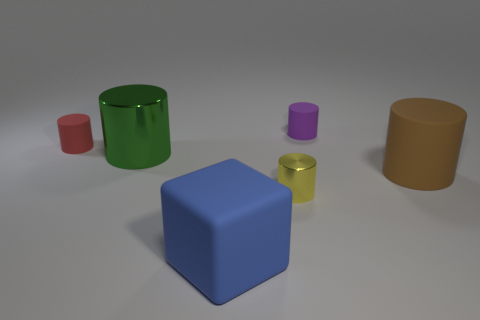Are there more big brown things that are left of the blue rubber thing than big metallic cylinders that are in front of the red rubber cylinder?
Make the answer very short. No. How many other things are there of the same size as the brown cylinder?
Offer a terse response. 2. Are the large cylinder to the right of the tiny purple matte cylinder and the green cylinder made of the same material?
Offer a very short reply. No. What number of other things are there of the same color as the big metal cylinder?
Provide a succinct answer. 0. How many other objects are there of the same shape as the blue object?
Provide a short and direct response. 0. Do the tiny thing behind the tiny red cylinder and the big thing behind the large brown thing have the same shape?
Provide a short and direct response. Yes. Is the number of small purple cylinders that are to the left of the small yellow metal thing the same as the number of brown matte cylinders that are behind the purple object?
Provide a short and direct response. Yes. The large matte thing left of the large cylinder that is on the right side of the big cylinder that is to the left of the block is what shape?
Provide a succinct answer. Cube. Does the tiny cylinder in front of the big brown rubber object have the same material as the small cylinder that is on the left side of the green metallic cylinder?
Your answer should be very brief. No. There is a small matte object that is on the right side of the red matte cylinder; what is its shape?
Keep it short and to the point. Cylinder. 